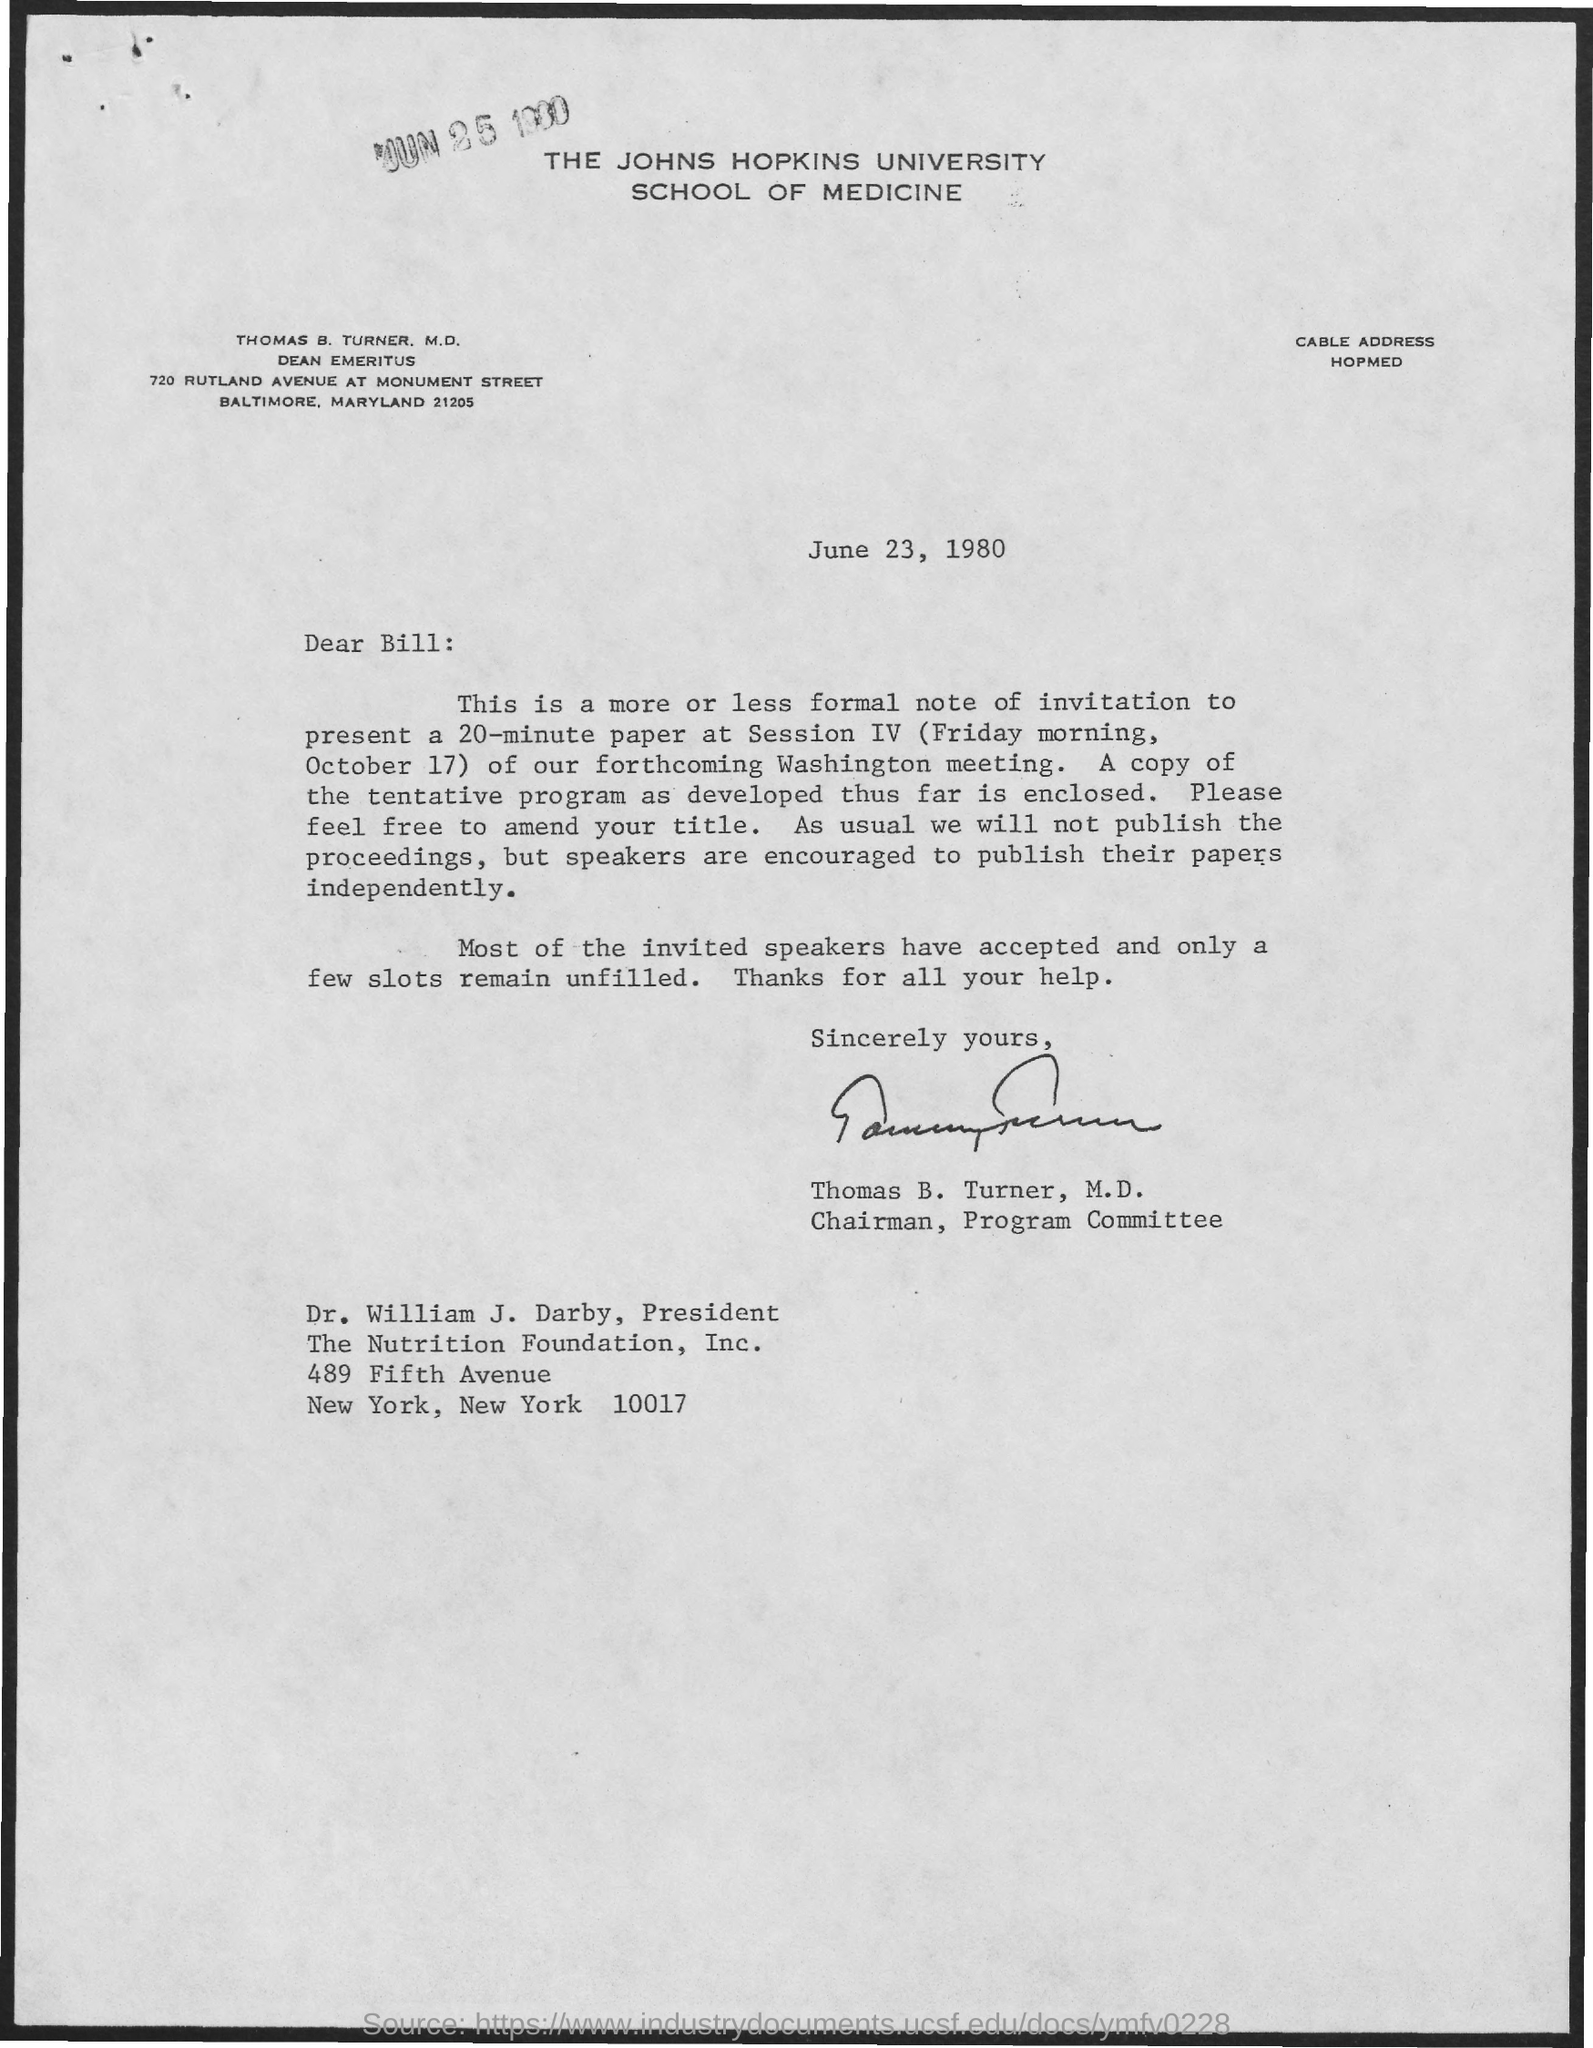Draw attention to some important aspects in this diagram. The sender of the message is Thomas B. Turner. 